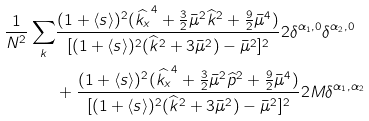Convert formula to latex. <formula><loc_0><loc_0><loc_500><loc_500>\frac { 1 } { N ^ { 2 } } \sum _ { k } & \frac { ( 1 + \langle s \rangle ) ^ { 2 } ( \widehat { k _ { x } } ^ { 4 } + \frac { 3 } { 2 } \bar { \mu } ^ { 2 } \widehat { k } ^ { 2 } + \frac { 9 } { 2 } \bar { \mu } ^ { 4 } ) } { [ ( 1 + \langle s \rangle ) ^ { 2 } ( \widehat { k } ^ { 2 } + 3 \bar { \mu } ^ { 2 } ) - \bar { \mu } ^ { 2 } ] ^ { 2 } } 2 \delta ^ { \alpha _ { 1 } , 0 } \delta ^ { \alpha _ { 2 } , 0 } \\ & + \frac { ( 1 + \langle s \rangle ) ^ { 2 } ( \widehat { k _ { x } } ^ { 4 } + \frac { 3 } { 2 } \bar { \mu } ^ { 2 } \widehat { p } ^ { 2 } + \frac { 9 } { 2 } \bar { \mu } ^ { 4 } ) } { [ ( 1 + \langle s \rangle ) ^ { 2 } ( \widehat { k } ^ { 2 } + 3 \bar { \mu } ^ { 2 } ) - \bar { \mu } ^ { 2 } ] ^ { 2 } } 2 M \delta ^ { \alpha _ { 1 } , \alpha _ { 2 } }</formula> 